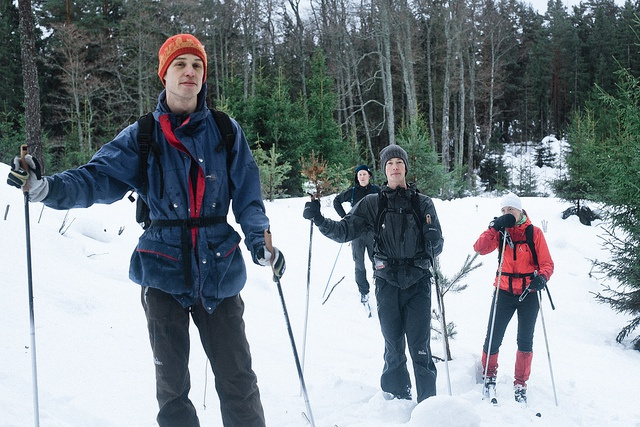Describe the objects in this image and their specific colors. I can see people in black, navy, darkblue, and gray tones, people in black, darkblue, blue, and gray tones, people in black, salmon, darkblue, and blue tones, backpack in black, navy, darkblue, and white tones, and people in black, darkblue, white, and gray tones in this image. 